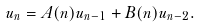<formula> <loc_0><loc_0><loc_500><loc_500>u _ { n } = A ( n ) u _ { n - 1 } + B ( n ) u _ { n - 2 } .</formula> 